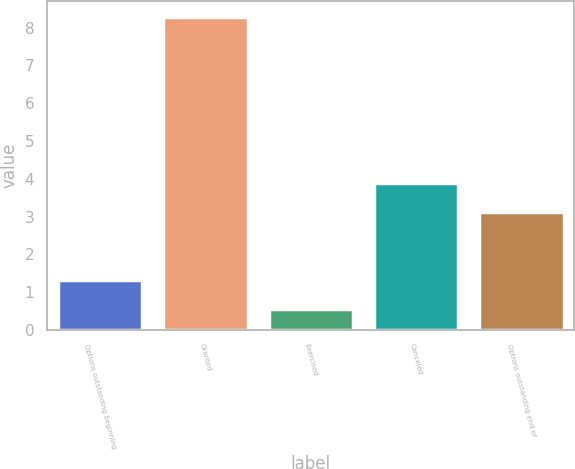<chart> <loc_0><loc_0><loc_500><loc_500><bar_chart><fcel>Options outstanding beginning<fcel>Granted<fcel>Exercised<fcel>Canceled<fcel>Options outstanding end of<nl><fcel>1.32<fcel>8.28<fcel>0.55<fcel>3.9<fcel>3.13<nl></chart> 